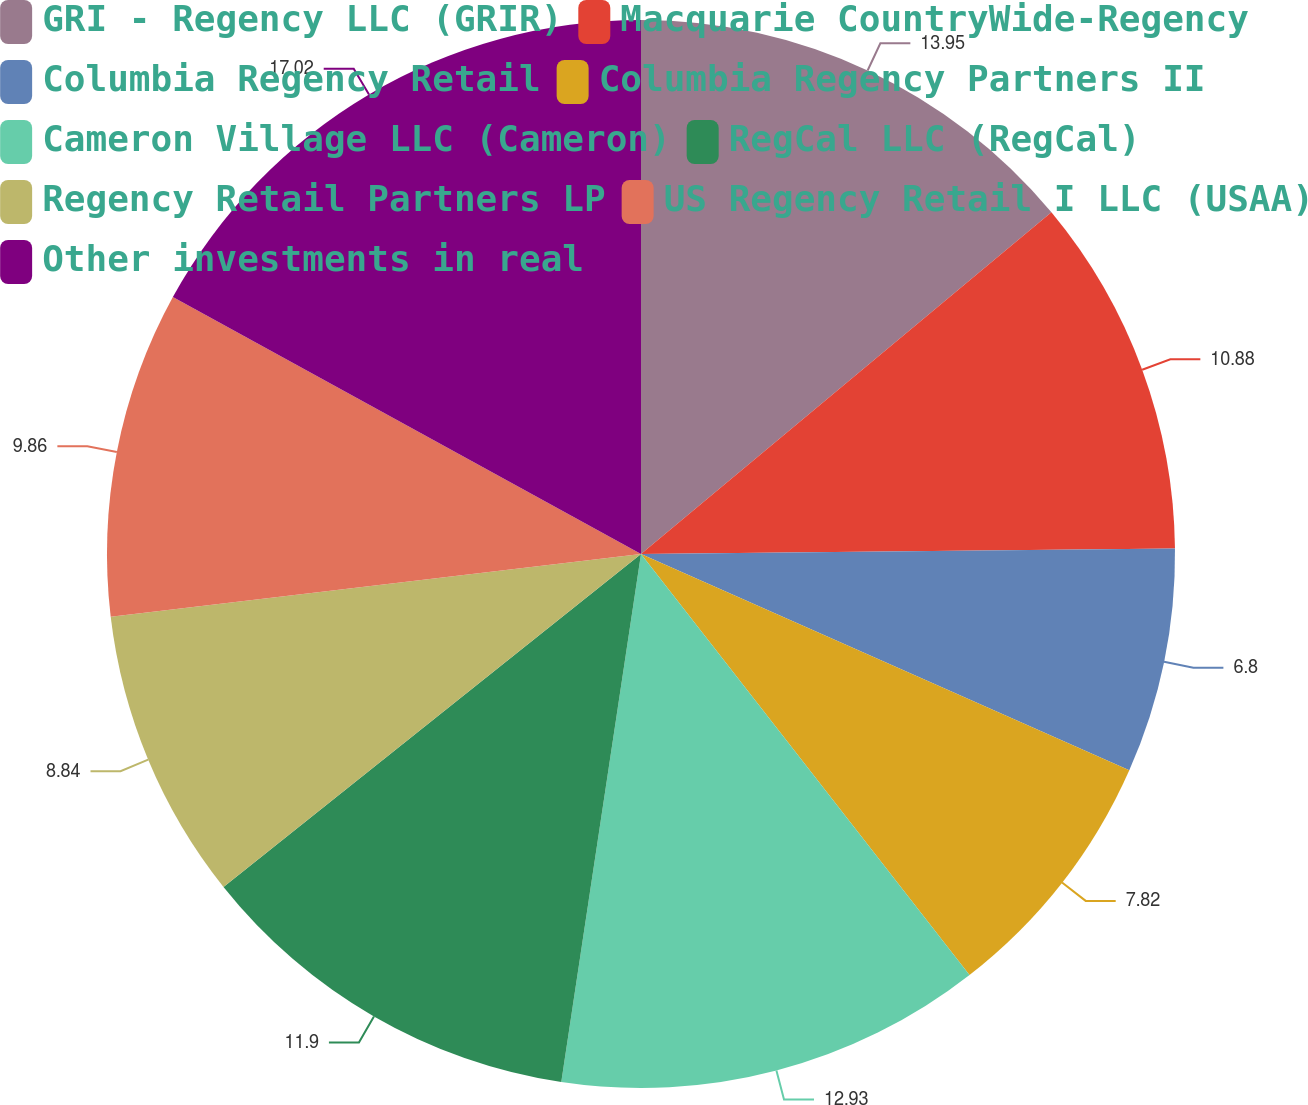<chart> <loc_0><loc_0><loc_500><loc_500><pie_chart><fcel>GRI - Regency LLC (GRIR)<fcel>Macquarie CountryWide-Regency<fcel>Columbia Regency Retail<fcel>Columbia Regency Partners II<fcel>Cameron Village LLC (Cameron)<fcel>RegCal LLC (RegCal)<fcel>Regency Retail Partners LP<fcel>US Regency Retail I LLC (USAA)<fcel>Other investments in real<nl><fcel>13.95%<fcel>10.88%<fcel>6.8%<fcel>7.82%<fcel>12.93%<fcel>11.9%<fcel>8.84%<fcel>9.86%<fcel>17.01%<nl></chart> 